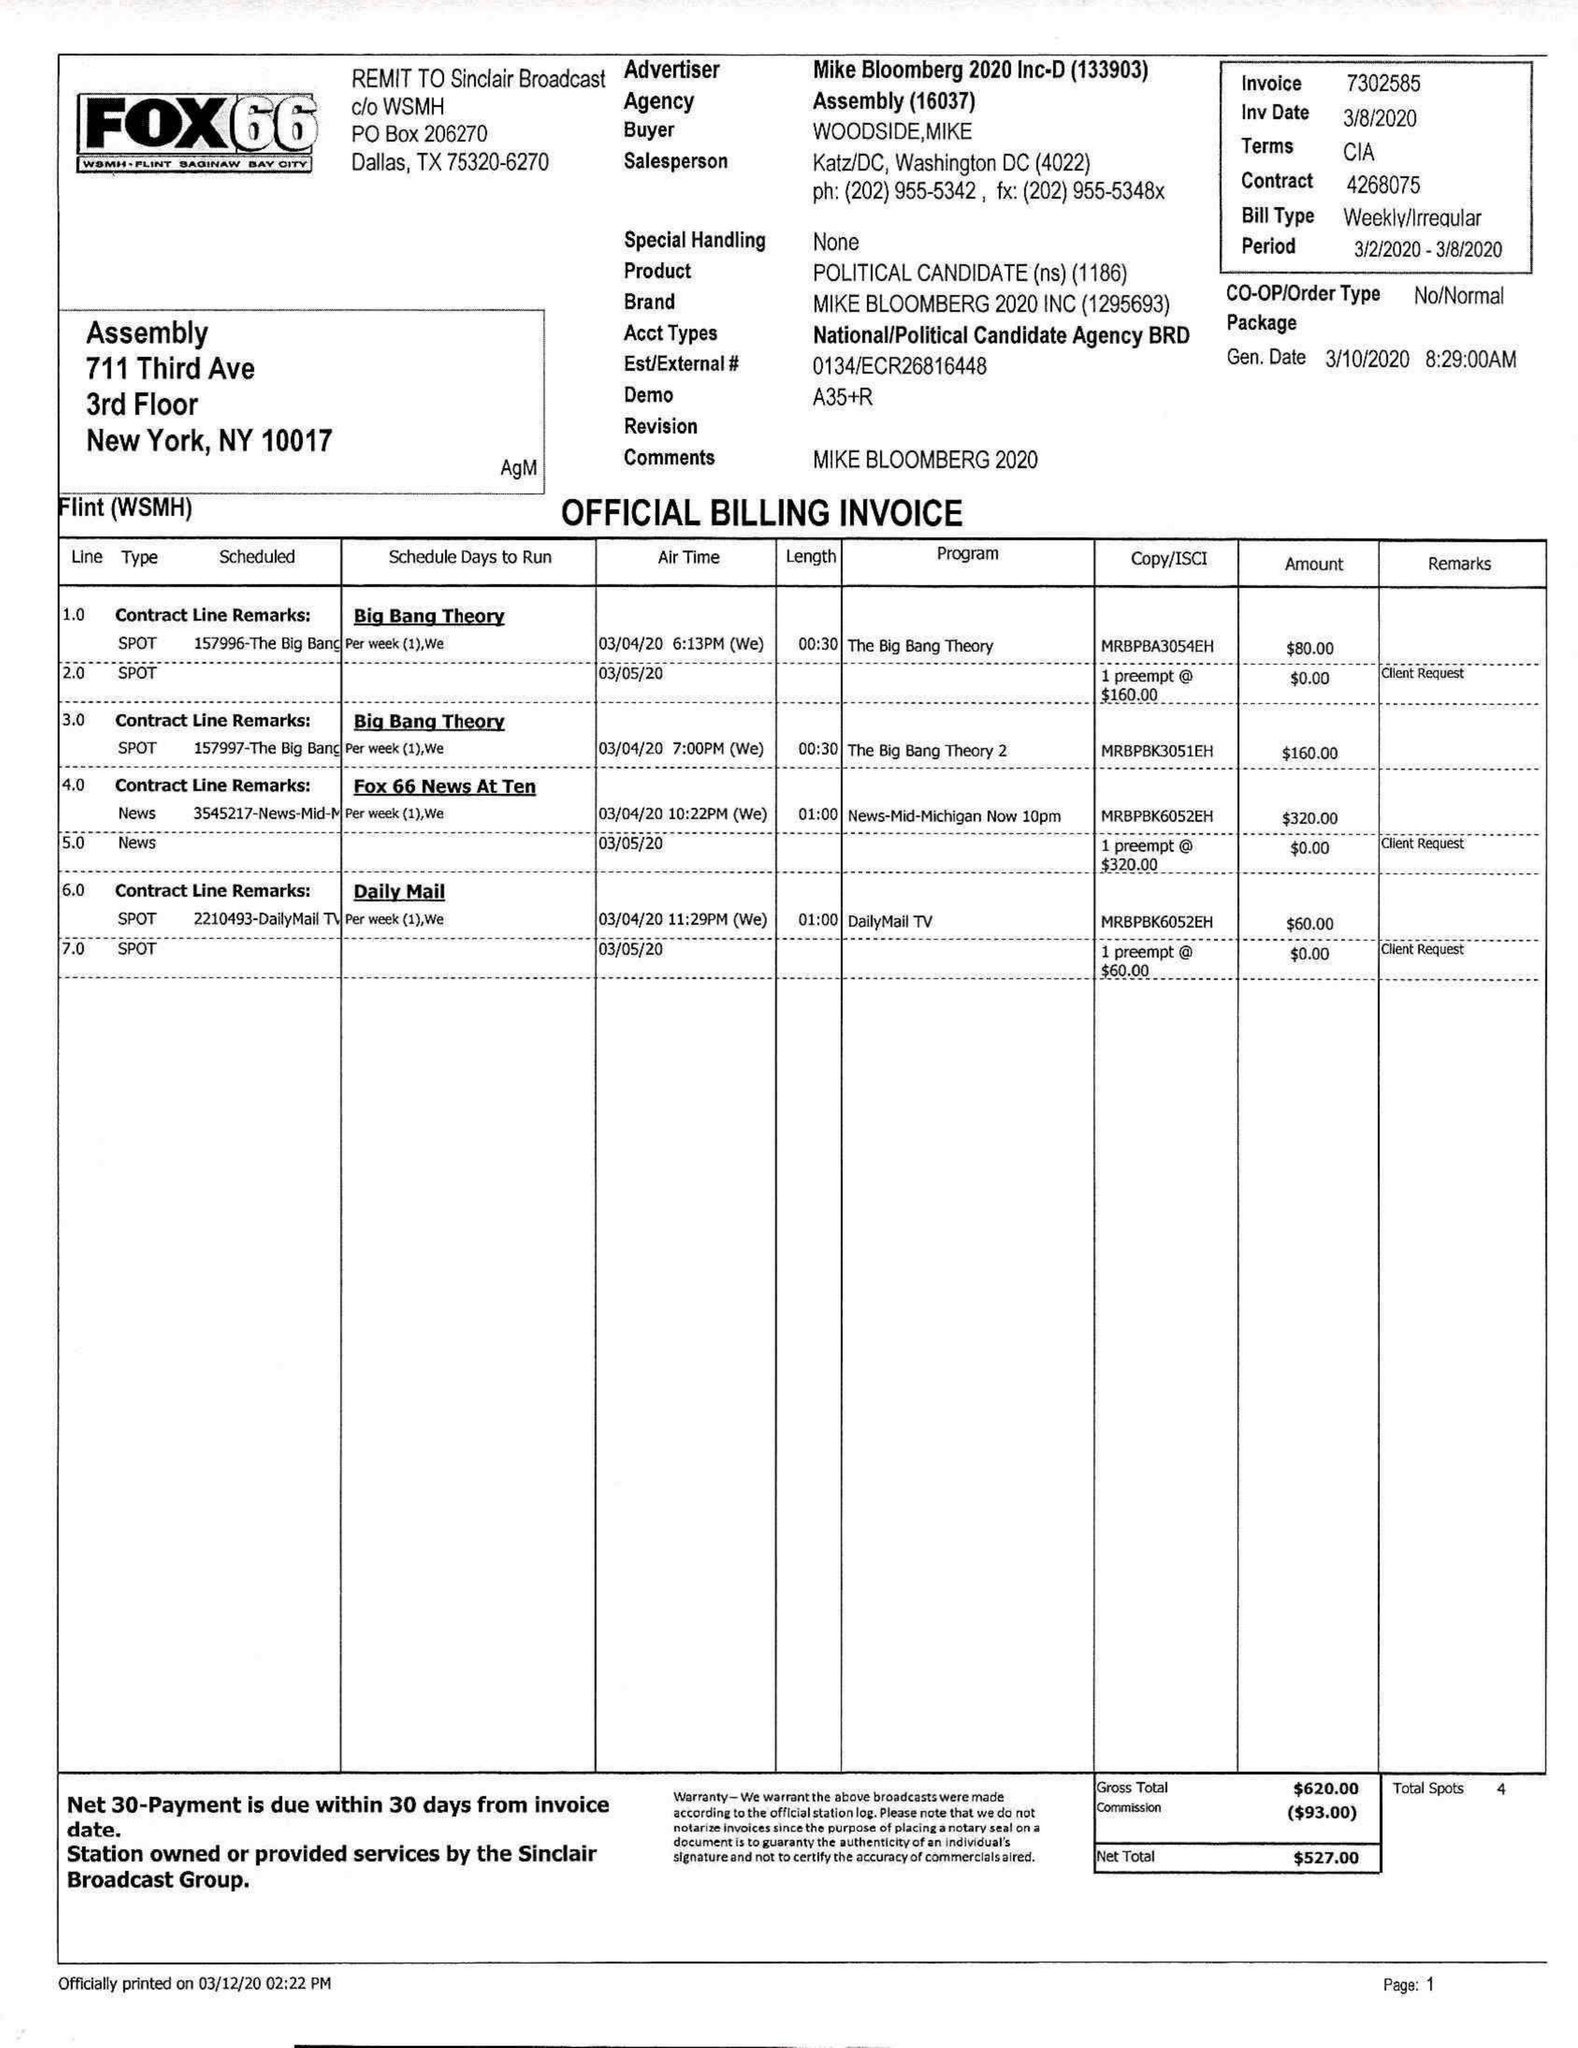What is the value for the advertiser?
Answer the question using a single word or phrase. MIKE BLOOMBERG 2020 INC-D 